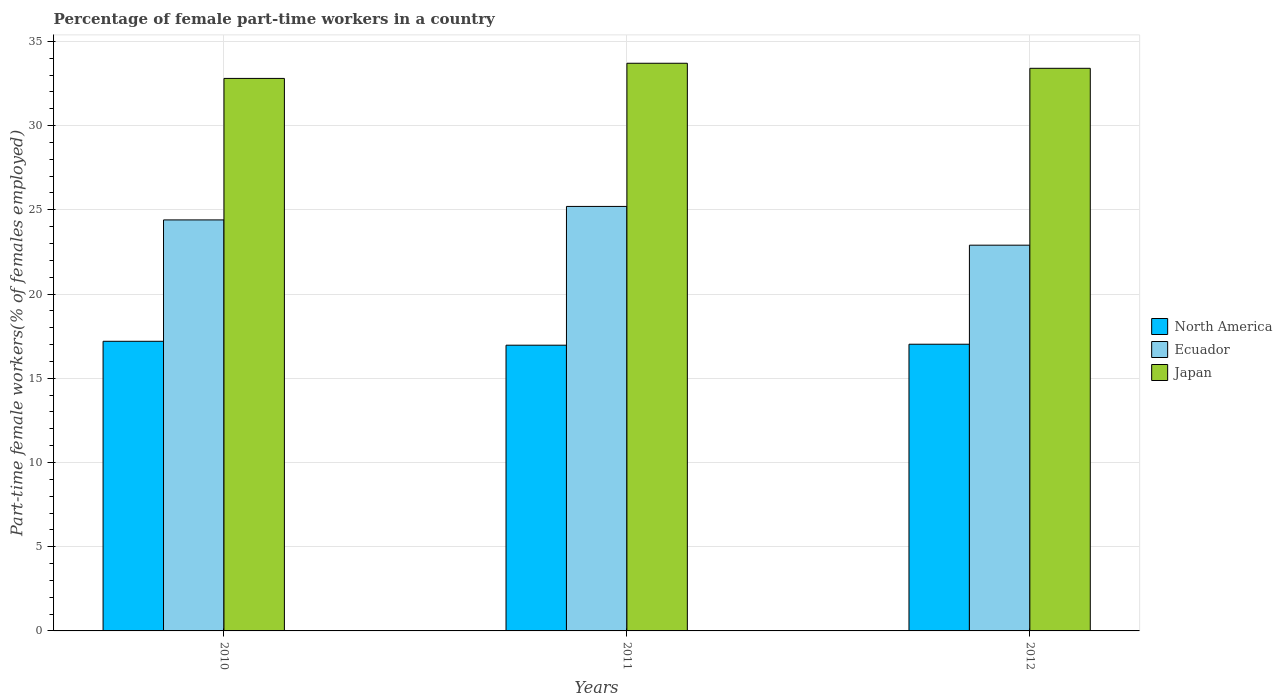Are the number of bars per tick equal to the number of legend labels?
Your answer should be compact. Yes. Are the number of bars on each tick of the X-axis equal?
Provide a succinct answer. Yes. How many bars are there on the 3rd tick from the right?
Offer a terse response. 3. What is the percentage of female part-time workers in Ecuador in 2012?
Your answer should be compact. 22.9. Across all years, what is the maximum percentage of female part-time workers in Ecuador?
Offer a terse response. 25.2. Across all years, what is the minimum percentage of female part-time workers in North America?
Offer a terse response. 16.96. In which year was the percentage of female part-time workers in Ecuador minimum?
Provide a short and direct response. 2012. What is the total percentage of female part-time workers in Japan in the graph?
Keep it short and to the point. 99.9. What is the difference between the percentage of female part-time workers in Ecuador in 2010 and that in 2011?
Keep it short and to the point. -0.8. What is the difference between the percentage of female part-time workers in Japan in 2010 and the percentage of female part-time workers in Ecuador in 2012?
Provide a short and direct response. 9.9. What is the average percentage of female part-time workers in North America per year?
Your answer should be very brief. 17.06. In the year 2010, what is the difference between the percentage of female part-time workers in Ecuador and percentage of female part-time workers in North America?
Make the answer very short. 7.21. What is the ratio of the percentage of female part-time workers in Japan in 2010 to that in 2012?
Make the answer very short. 0.98. Is the percentage of female part-time workers in Japan in 2011 less than that in 2012?
Make the answer very short. No. Is the difference between the percentage of female part-time workers in Ecuador in 2010 and 2011 greater than the difference between the percentage of female part-time workers in North America in 2010 and 2011?
Ensure brevity in your answer.  No. What is the difference between the highest and the second highest percentage of female part-time workers in Japan?
Your answer should be compact. 0.3. What is the difference between the highest and the lowest percentage of female part-time workers in Japan?
Your answer should be very brief. 0.9. In how many years, is the percentage of female part-time workers in Japan greater than the average percentage of female part-time workers in Japan taken over all years?
Offer a very short reply. 2. Is the sum of the percentage of female part-time workers in North America in 2010 and 2012 greater than the maximum percentage of female part-time workers in Japan across all years?
Ensure brevity in your answer.  Yes. What does the 2nd bar from the left in 2010 represents?
Give a very brief answer. Ecuador. What does the 1st bar from the right in 2011 represents?
Offer a terse response. Japan. How many bars are there?
Keep it short and to the point. 9. How many years are there in the graph?
Give a very brief answer. 3. What is the difference between two consecutive major ticks on the Y-axis?
Make the answer very short. 5. Are the values on the major ticks of Y-axis written in scientific E-notation?
Offer a terse response. No. Does the graph contain any zero values?
Your answer should be compact. No. Does the graph contain grids?
Your answer should be compact. Yes. How many legend labels are there?
Ensure brevity in your answer.  3. How are the legend labels stacked?
Keep it short and to the point. Vertical. What is the title of the graph?
Your response must be concise. Percentage of female part-time workers in a country. What is the label or title of the Y-axis?
Your response must be concise. Part-time female workers(% of females employed). What is the Part-time female workers(% of females employed) in North America in 2010?
Keep it short and to the point. 17.19. What is the Part-time female workers(% of females employed) in Ecuador in 2010?
Your answer should be compact. 24.4. What is the Part-time female workers(% of females employed) of Japan in 2010?
Offer a terse response. 32.8. What is the Part-time female workers(% of females employed) of North America in 2011?
Your answer should be compact. 16.96. What is the Part-time female workers(% of females employed) of Ecuador in 2011?
Offer a terse response. 25.2. What is the Part-time female workers(% of females employed) of Japan in 2011?
Offer a very short reply. 33.7. What is the Part-time female workers(% of females employed) in North America in 2012?
Your answer should be compact. 17.02. What is the Part-time female workers(% of females employed) in Ecuador in 2012?
Keep it short and to the point. 22.9. What is the Part-time female workers(% of females employed) in Japan in 2012?
Provide a short and direct response. 33.4. Across all years, what is the maximum Part-time female workers(% of females employed) of North America?
Offer a very short reply. 17.19. Across all years, what is the maximum Part-time female workers(% of females employed) in Ecuador?
Offer a very short reply. 25.2. Across all years, what is the maximum Part-time female workers(% of females employed) in Japan?
Give a very brief answer. 33.7. Across all years, what is the minimum Part-time female workers(% of females employed) in North America?
Your answer should be very brief. 16.96. Across all years, what is the minimum Part-time female workers(% of females employed) of Ecuador?
Give a very brief answer. 22.9. Across all years, what is the minimum Part-time female workers(% of females employed) of Japan?
Your response must be concise. 32.8. What is the total Part-time female workers(% of females employed) of North America in the graph?
Your response must be concise. 51.18. What is the total Part-time female workers(% of females employed) of Ecuador in the graph?
Make the answer very short. 72.5. What is the total Part-time female workers(% of females employed) of Japan in the graph?
Provide a short and direct response. 99.9. What is the difference between the Part-time female workers(% of females employed) of North America in 2010 and that in 2011?
Keep it short and to the point. 0.23. What is the difference between the Part-time female workers(% of females employed) of North America in 2010 and that in 2012?
Offer a terse response. 0.17. What is the difference between the Part-time female workers(% of females employed) in Ecuador in 2010 and that in 2012?
Offer a terse response. 1.5. What is the difference between the Part-time female workers(% of females employed) of North America in 2011 and that in 2012?
Ensure brevity in your answer.  -0.06. What is the difference between the Part-time female workers(% of females employed) of Ecuador in 2011 and that in 2012?
Provide a succinct answer. 2.3. What is the difference between the Part-time female workers(% of females employed) of North America in 2010 and the Part-time female workers(% of females employed) of Ecuador in 2011?
Provide a short and direct response. -8.01. What is the difference between the Part-time female workers(% of females employed) in North America in 2010 and the Part-time female workers(% of females employed) in Japan in 2011?
Your answer should be compact. -16.51. What is the difference between the Part-time female workers(% of females employed) of Ecuador in 2010 and the Part-time female workers(% of females employed) of Japan in 2011?
Ensure brevity in your answer.  -9.3. What is the difference between the Part-time female workers(% of females employed) in North America in 2010 and the Part-time female workers(% of females employed) in Ecuador in 2012?
Offer a very short reply. -5.71. What is the difference between the Part-time female workers(% of females employed) of North America in 2010 and the Part-time female workers(% of females employed) of Japan in 2012?
Offer a terse response. -16.21. What is the difference between the Part-time female workers(% of females employed) of North America in 2011 and the Part-time female workers(% of females employed) of Ecuador in 2012?
Offer a very short reply. -5.94. What is the difference between the Part-time female workers(% of females employed) of North America in 2011 and the Part-time female workers(% of females employed) of Japan in 2012?
Give a very brief answer. -16.44. What is the average Part-time female workers(% of females employed) in North America per year?
Provide a succinct answer. 17.06. What is the average Part-time female workers(% of females employed) of Ecuador per year?
Offer a very short reply. 24.17. What is the average Part-time female workers(% of females employed) in Japan per year?
Your response must be concise. 33.3. In the year 2010, what is the difference between the Part-time female workers(% of females employed) in North America and Part-time female workers(% of females employed) in Ecuador?
Offer a very short reply. -7.21. In the year 2010, what is the difference between the Part-time female workers(% of females employed) of North America and Part-time female workers(% of females employed) of Japan?
Keep it short and to the point. -15.61. In the year 2011, what is the difference between the Part-time female workers(% of females employed) in North America and Part-time female workers(% of females employed) in Ecuador?
Your response must be concise. -8.24. In the year 2011, what is the difference between the Part-time female workers(% of females employed) in North America and Part-time female workers(% of females employed) in Japan?
Your response must be concise. -16.74. In the year 2011, what is the difference between the Part-time female workers(% of females employed) in Ecuador and Part-time female workers(% of females employed) in Japan?
Offer a terse response. -8.5. In the year 2012, what is the difference between the Part-time female workers(% of females employed) in North America and Part-time female workers(% of females employed) in Ecuador?
Your answer should be compact. -5.88. In the year 2012, what is the difference between the Part-time female workers(% of females employed) of North America and Part-time female workers(% of females employed) of Japan?
Make the answer very short. -16.38. What is the ratio of the Part-time female workers(% of females employed) in North America in 2010 to that in 2011?
Your answer should be compact. 1.01. What is the ratio of the Part-time female workers(% of females employed) in Ecuador in 2010 to that in 2011?
Your response must be concise. 0.97. What is the ratio of the Part-time female workers(% of females employed) in Japan in 2010 to that in 2011?
Your response must be concise. 0.97. What is the ratio of the Part-time female workers(% of females employed) of North America in 2010 to that in 2012?
Offer a very short reply. 1.01. What is the ratio of the Part-time female workers(% of females employed) of Ecuador in 2010 to that in 2012?
Offer a terse response. 1.07. What is the ratio of the Part-time female workers(% of females employed) of Ecuador in 2011 to that in 2012?
Provide a succinct answer. 1.1. What is the ratio of the Part-time female workers(% of females employed) in Japan in 2011 to that in 2012?
Ensure brevity in your answer.  1.01. What is the difference between the highest and the second highest Part-time female workers(% of females employed) in North America?
Your answer should be very brief. 0.17. What is the difference between the highest and the second highest Part-time female workers(% of females employed) of Ecuador?
Offer a very short reply. 0.8. What is the difference between the highest and the second highest Part-time female workers(% of females employed) of Japan?
Your answer should be very brief. 0.3. What is the difference between the highest and the lowest Part-time female workers(% of females employed) of North America?
Your response must be concise. 0.23. What is the difference between the highest and the lowest Part-time female workers(% of females employed) in Ecuador?
Your answer should be compact. 2.3. What is the difference between the highest and the lowest Part-time female workers(% of females employed) of Japan?
Your answer should be very brief. 0.9. 